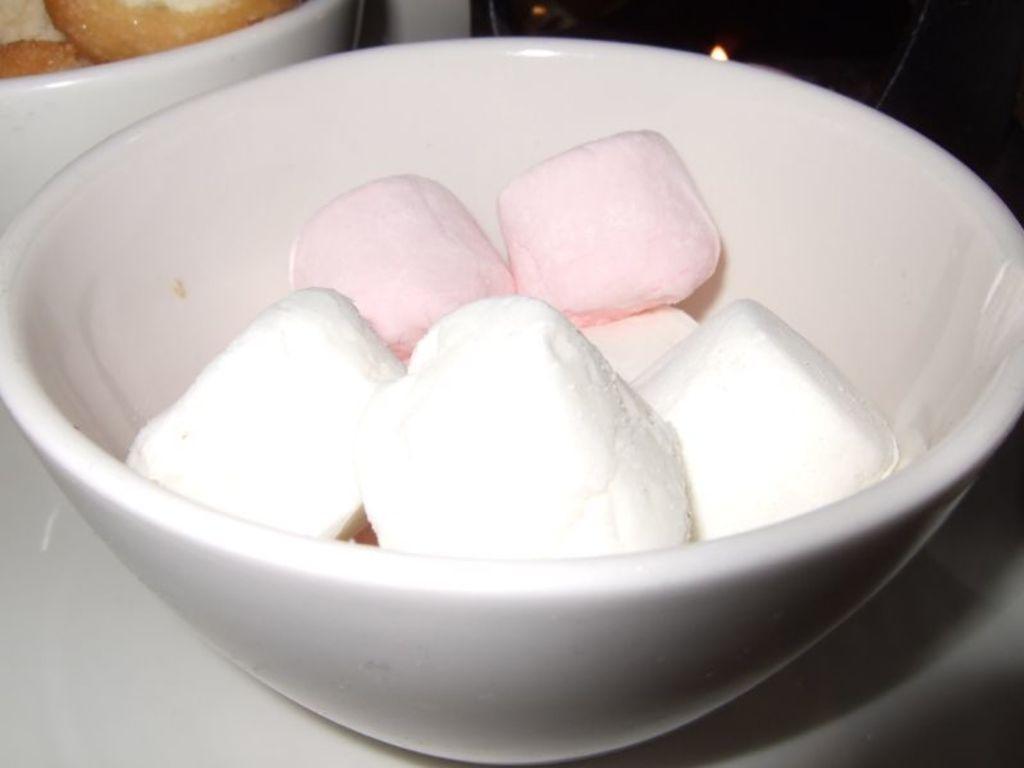Can you describe this image briefly? In this picture I can observe marshmallows which are in white and pink color in the bowl. The bowl is in white color. 